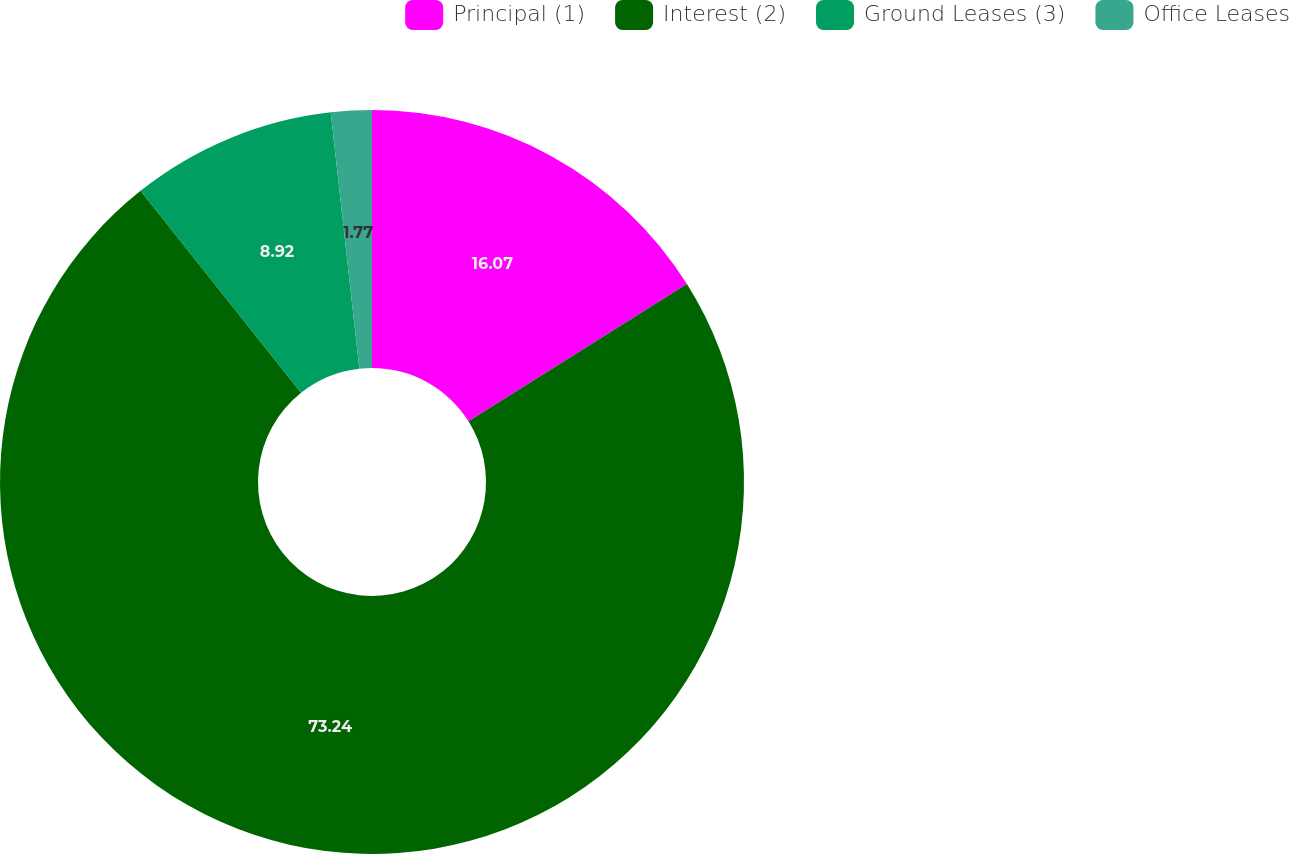Convert chart. <chart><loc_0><loc_0><loc_500><loc_500><pie_chart><fcel>Principal (1)<fcel>Interest (2)<fcel>Ground Leases (3)<fcel>Office Leases<nl><fcel>16.07%<fcel>73.25%<fcel>8.92%<fcel>1.77%<nl></chart> 